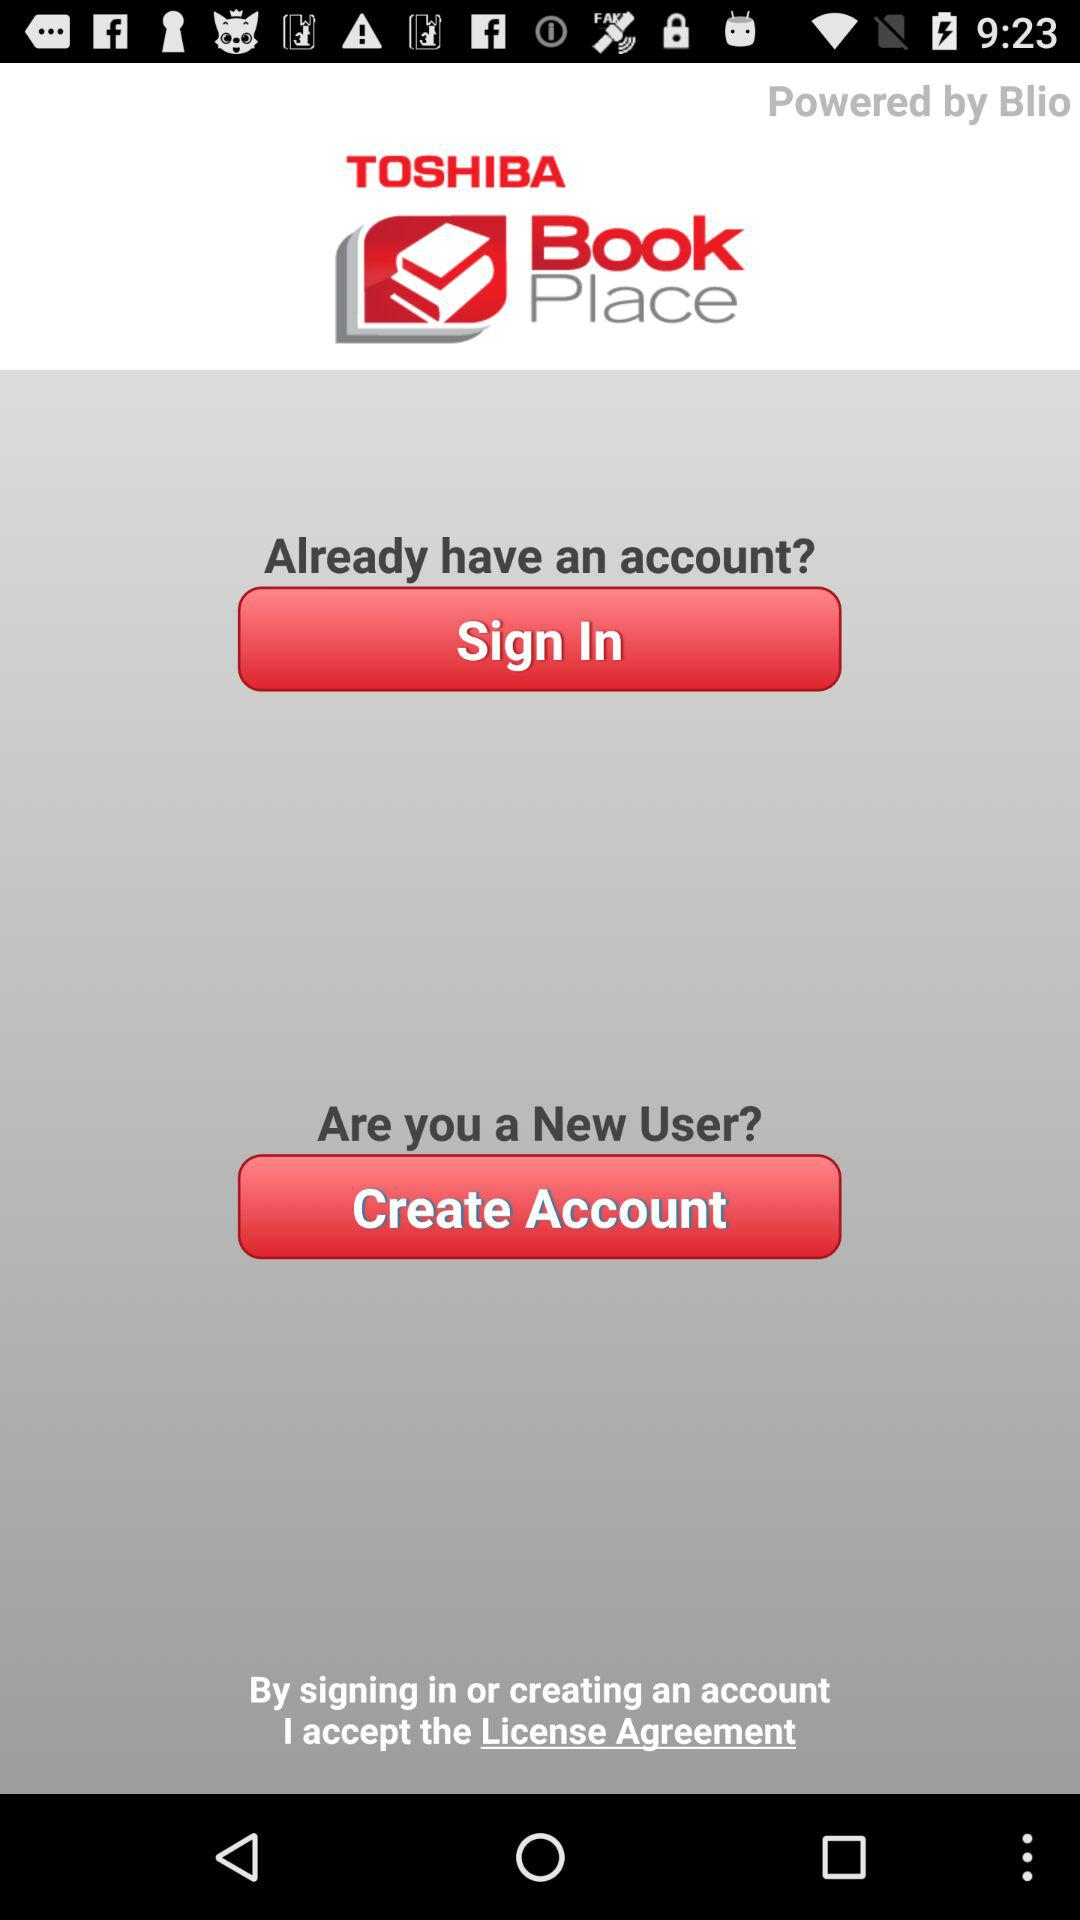What is the name of the application? The application name is "TOSHIBA Book Place". 